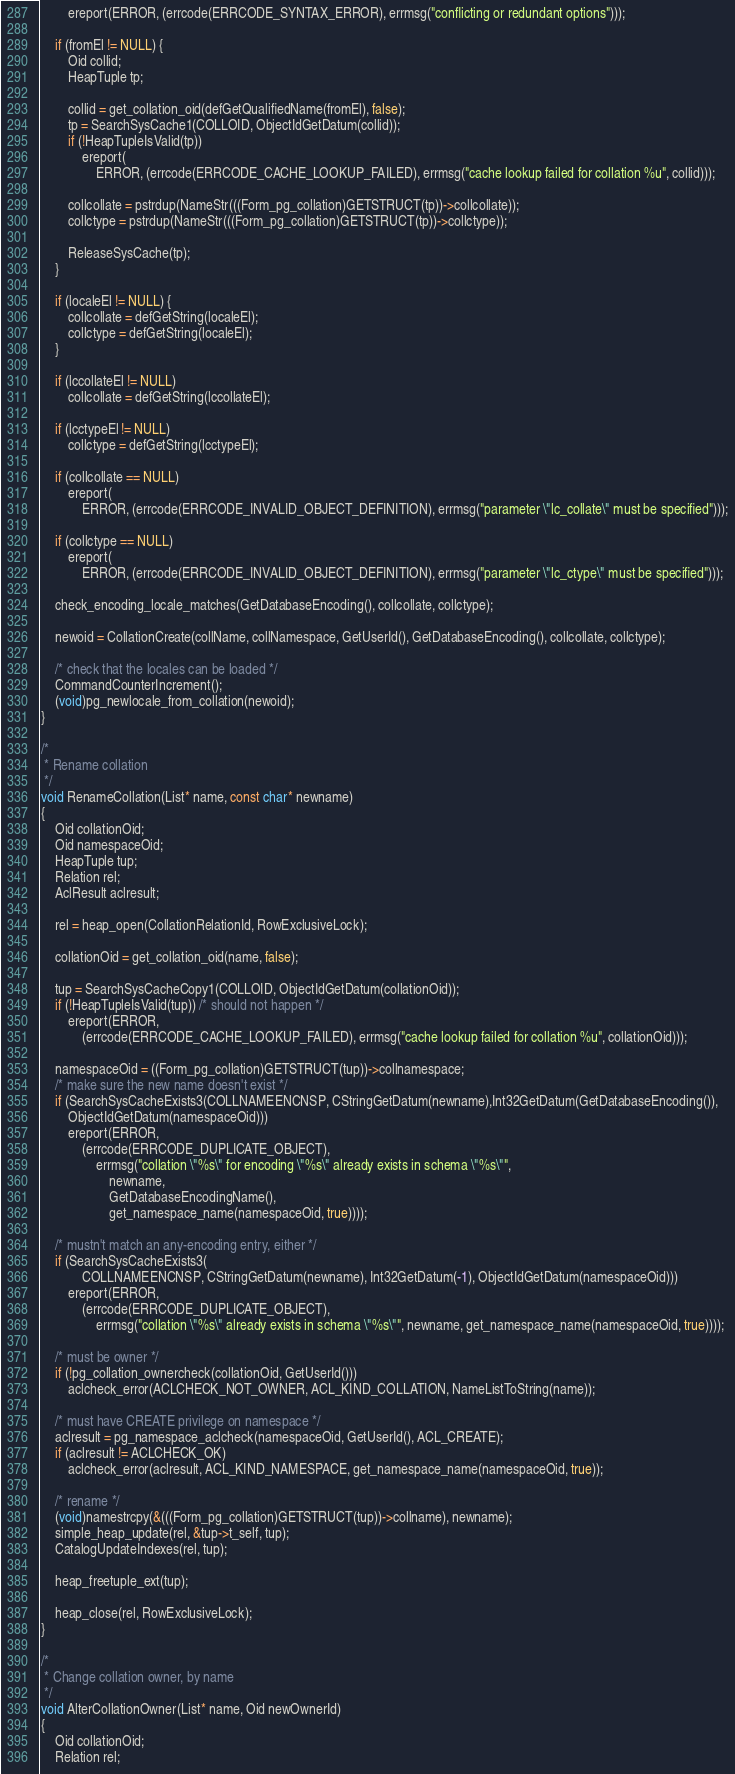Convert code to text. <code><loc_0><loc_0><loc_500><loc_500><_C++_>        ereport(ERROR, (errcode(ERRCODE_SYNTAX_ERROR), errmsg("conflicting or redundant options")));

    if (fromEl != NULL) {
        Oid collid;
        HeapTuple tp;

        collid = get_collation_oid(defGetQualifiedName(fromEl), false);
        tp = SearchSysCache1(COLLOID, ObjectIdGetDatum(collid));
        if (!HeapTupleIsValid(tp))
            ereport(
                ERROR, (errcode(ERRCODE_CACHE_LOOKUP_FAILED), errmsg("cache lookup failed for collation %u", collid)));

        collcollate = pstrdup(NameStr(((Form_pg_collation)GETSTRUCT(tp))->collcollate));
        collctype = pstrdup(NameStr(((Form_pg_collation)GETSTRUCT(tp))->collctype));

        ReleaseSysCache(tp);
    }

    if (localeEl != NULL) {
        collcollate = defGetString(localeEl);
        collctype = defGetString(localeEl);
    }

    if (lccollateEl != NULL)
        collcollate = defGetString(lccollateEl);

    if (lcctypeEl != NULL)
        collctype = defGetString(lcctypeEl);

    if (collcollate == NULL)
        ereport(
            ERROR, (errcode(ERRCODE_INVALID_OBJECT_DEFINITION), errmsg("parameter \"lc_collate\" must be specified")));

    if (collctype == NULL)
        ereport(
            ERROR, (errcode(ERRCODE_INVALID_OBJECT_DEFINITION), errmsg("parameter \"lc_ctype\" must be specified")));

    check_encoding_locale_matches(GetDatabaseEncoding(), collcollate, collctype);

    newoid = CollationCreate(collName, collNamespace, GetUserId(), GetDatabaseEncoding(), collcollate, collctype);

    /* check that the locales can be loaded */
    CommandCounterIncrement();
    (void)pg_newlocale_from_collation(newoid);
}

/*
 * Rename collation
 */
void RenameCollation(List* name, const char* newname)
{
    Oid collationOid;
    Oid namespaceOid;
    HeapTuple tup;
    Relation rel;
    AclResult aclresult;

    rel = heap_open(CollationRelationId, RowExclusiveLock);

    collationOid = get_collation_oid(name, false);

    tup = SearchSysCacheCopy1(COLLOID, ObjectIdGetDatum(collationOid));
    if (!HeapTupleIsValid(tup)) /* should not happen */
        ereport(ERROR,
            (errcode(ERRCODE_CACHE_LOOKUP_FAILED), errmsg("cache lookup failed for collation %u", collationOid)));

    namespaceOid = ((Form_pg_collation)GETSTRUCT(tup))->collnamespace;
    /* make sure the new name doesn't exist */
    if (SearchSysCacheExists3(COLLNAMEENCNSP, CStringGetDatum(newname),Int32GetDatum(GetDatabaseEncoding()),
        ObjectIdGetDatum(namespaceOid)))
        ereport(ERROR,
            (errcode(ERRCODE_DUPLICATE_OBJECT),
                errmsg("collation \"%s\" for encoding \"%s\" already exists in schema \"%s\"",
                    newname,
                    GetDatabaseEncodingName(),
                    get_namespace_name(namespaceOid, true))));

    /* mustn't match an any-encoding entry, either */
    if (SearchSysCacheExists3(
            COLLNAMEENCNSP, CStringGetDatum(newname), Int32GetDatum(-1), ObjectIdGetDatum(namespaceOid)))
        ereport(ERROR,
            (errcode(ERRCODE_DUPLICATE_OBJECT),
                errmsg("collation \"%s\" already exists in schema \"%s\"", newname, get_namespace_name(namespaceOid, true))));

    /* must be owner */
    if (!pg_collation_ownercheck(collationOid, GetUserId()))
        aclcheck_error(ACLCHECK_NOT_OWNER, ACL_KIND_COLLATION, NameListToString(name));

    /* must have CREATE privilege on namespace */
    aclresult = pg_namespace_aclcheck(namespaceOid, GetUserId(), ACL_CREATE);
    if (aclresult != ACLCHECK_OK)
        aclcheck_error(aclresult, ACL_KIND_NAMESPACE, get_namespace_name(namespaceOid, true));

    /* rename */
    (void)namestrcpy(&(((Form_pg_collation)GETSTRUCT(tup))->collname), newname);
    simple_heap_update(rel, &tup->t_self, tup);
    CatalogUpdateIndexes(rel, tup);

    heap_freetuple_ext(tup);

    heap_close(rel, RowExclusiveLock);
}

/*
 * Change collation owner, by name
 */
void AlterCollationOwner(List* name, Oid newOwnerId)
{
    Oid collationOid;
    Relation rel;
</code> 